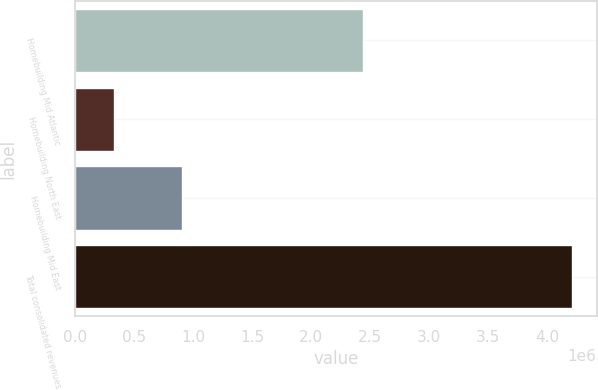<chart> <loc_0><loc_0><loc_500><loc_500><bar_chart><fcel>Homebuilding Mid Atlantic<fcel>Homebuilding North East<fcel>Homebuilding Mid East<fcel>Total consolidated revenues<nl><fcel>2.43939e+06<fcel>332681<fcel>908198<fcel>4.21127e+06<nl></chart> 